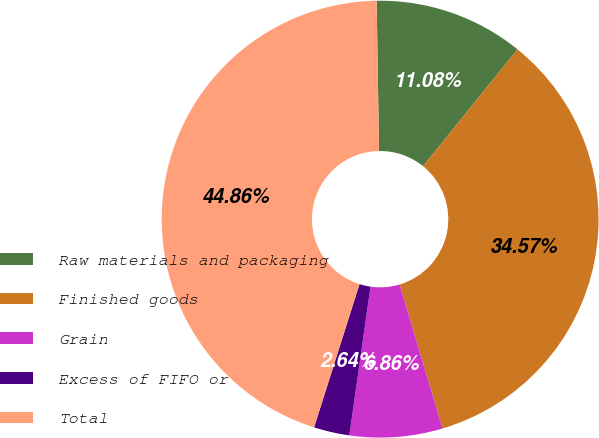<chart> <loc_0><loc_0><loc_500><loc_500><pie_chart><fcel>Raw materials and packaging<fcel>Finished goods<fcel>Grain<fcel>Excess of FIFO or<fcel>Total<nl><fcel>11.08%<fcel>34.57%<fcel>6.86%<fcel>2.64%<fcel>44.86%<nl></chart> 